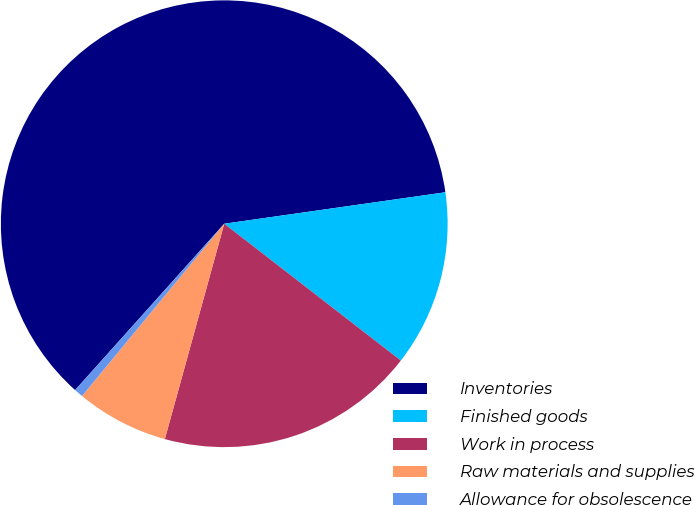<chart> <loc_0><loc_0><loc_500><loc_500><pie_chart><fcel>Inventories<fcel>Finished goods<fcel>Work in process<fcel>Raw materials and supplies<fcel>Allowance for obsolescence<nl><fcel>61.11%<fcel>12.74%<fcel>18.79%<fcel>6.7%<fcel>0.65%<nl></chart> 